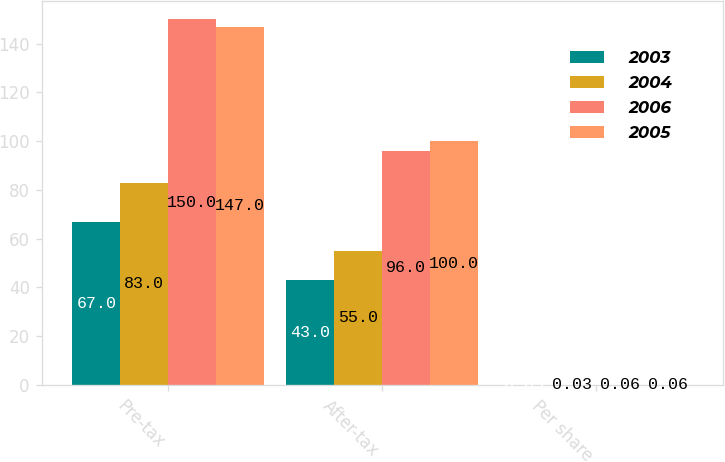Convert chart. <chart><loc_0><loc_0><loc_500><loc_500><stacked_bar_chart><ecel><fcel>Pre-tax<fcel>After-tax<fcel>Per share<nl><fcel>2003<fcel>67<fcel>43<fcel>0.03<nl><fcel>2004<fcel>83<fcel>55<fcel>0.03<nl><fcel>2006<fcel>150<fcel>96<fcel>0.06<nl><fcel>2005<fcel>147<fcel>100<fcel>0.06<nl></chart> 